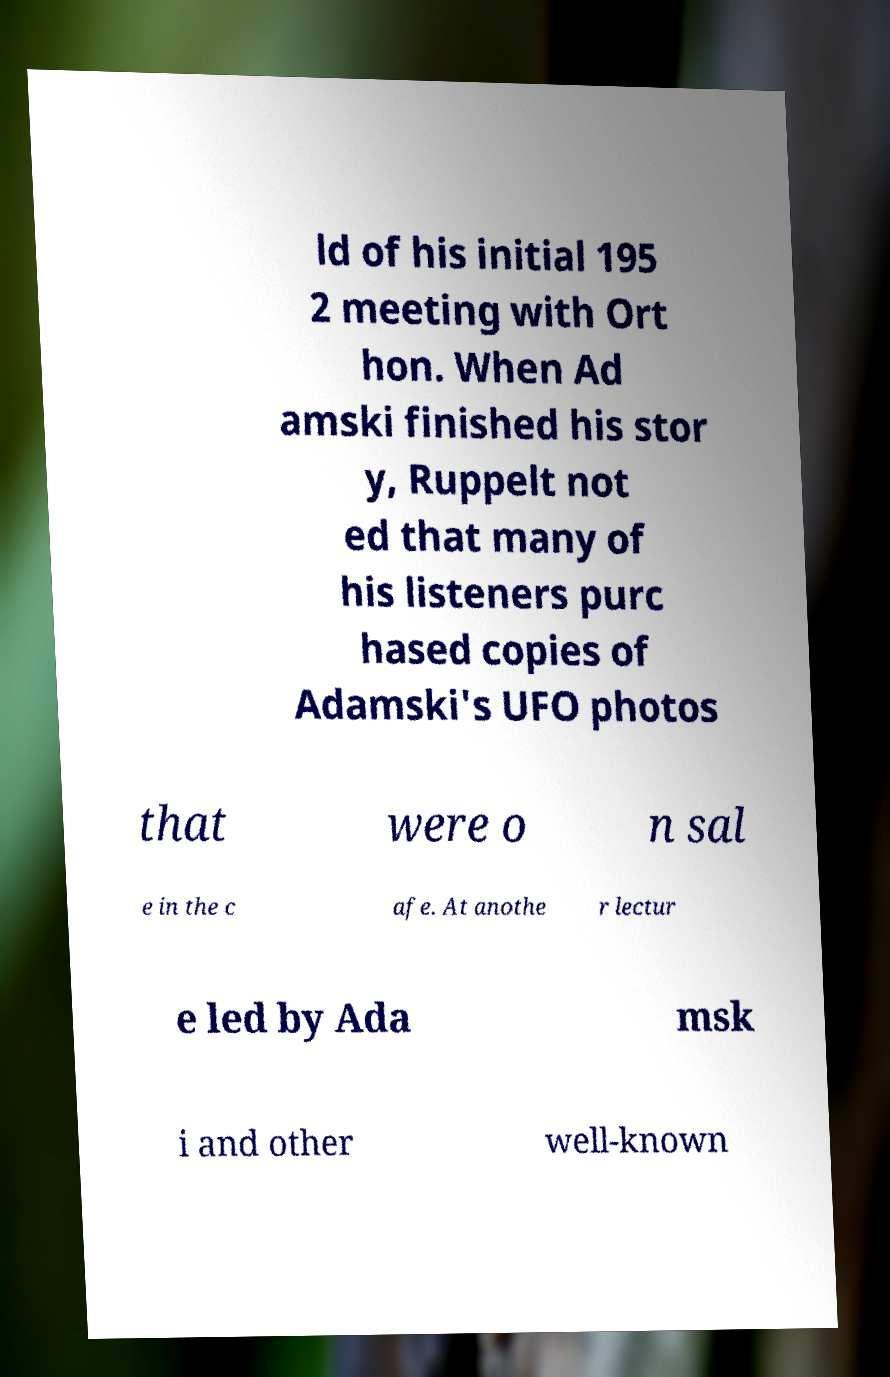There's text embedded in this image that I need extracted. Can you transcribe it verbatim? ld of his initial 195 2 meeting with Ort hon. When Ad amski finished his stor y, Ruppelt not ed that many of his listeners purc hased copies of Adamski's UFO photos that were o n sal e in the c afe. At anothe r lectur e led by Ada msk i and other well-known 